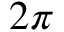<formula> <loc_0><loc_0><loc_500><loc_500>2 \pi</formula> 